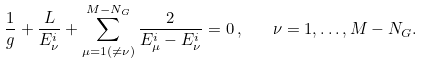<formula> <loc_0><loc_0><loc_500><loc_500>\frac { 1 } { g } + \frac { L } { E ^ { i } _ { \nu } } + \sum _ { \mu = 1 ( \neq \nu ) } ^ { M - N _ { G } } \frac { 2 } { E ^ { i } _ { \mu } - E ^ { i } _ { \nu } } = 0 \, , \quad \nu = 1 , \dots , M - N _ { G } .</formula> 